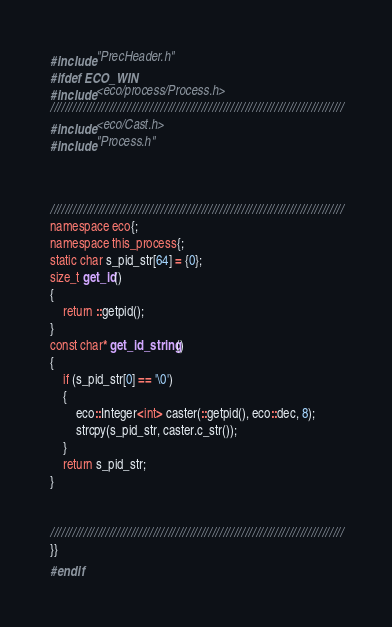Convert code to text. <code><loc_0><loc_0><loc_500><loc_500><_C++_>#include "PrecHeader.h"
#ifdef ECO_WIN
#include <eco/process/Process.h>
////////////////////////////////////////////////////////////////////////////////
#include <eco/Cast.h>
#include "Process.h"



////////////////////////////////////////////////////////////////////////////////
namespace eco{;
namespace this_process{;
static char s_pid_str[64] = {0};
size_t get_id()
{
	return ::getpid();
}
const char* get_id_string()
{
	if (s_pid_str[0] == '\0')
	{
		eco::Integer<int> caster(::getpid(), eco::dec, 8);
		strcpy(s_pid_str, caster.c_str());
	}
	return s_pid_str;
}


////////////////////////////////////////////////////////////////////////////////
}}
#endif</code> 